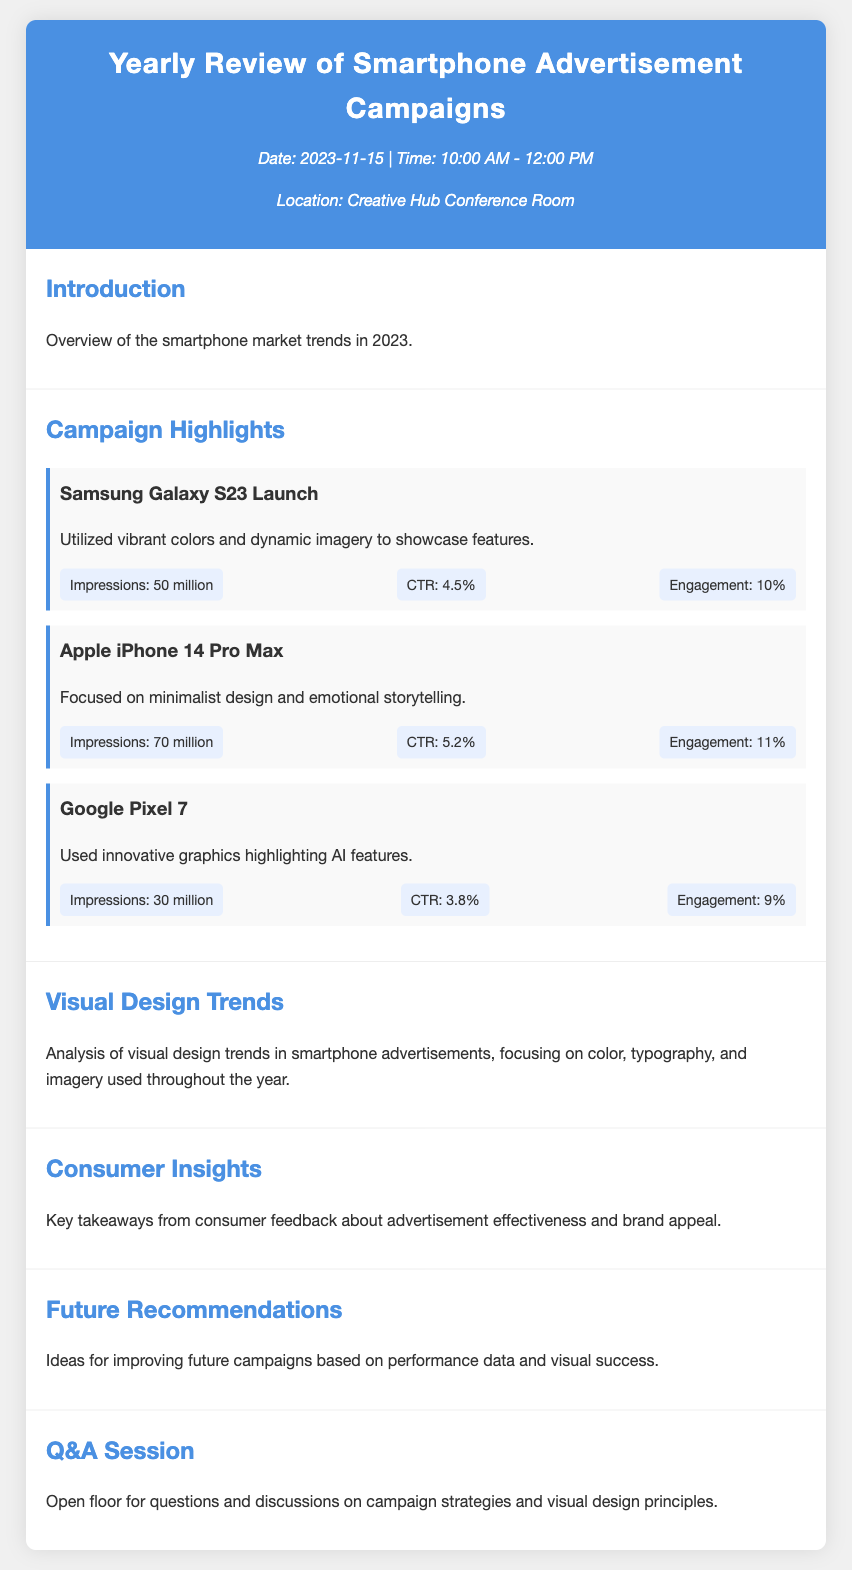What is the date of the review? The date is specified in the header of the document as 2023-11-15.
Answer: 2023-11-15 What is the engagement rate for the Apple iPhone 14 Pro Max campaign? The engagement rate is listed under the campaign highlights for Apple iPhone 14 Pro Max, which is 11%.
Answer: 11% How many impressions were achieved by the Samsung Galaxy S23 Launch? The impressions figure is provided in the campaign section for Samsung Galaxy S23, which is 50 million.
Answer: 50 million What design approach was emphasized in the Google Pixel 7 advertisement? The document states that the Google Pixel 7 used innovative graphics highlighting AI features.
Answer: Innovative graphics Which campaign had the highest click-through rate (CTR)? The CTRs are compared in the campaign highlights, revealing the Apple iPhone 14 Pro Max had the highest at 5.2%.
Answer: 5.2% What overall trend does the document analyze in the Visual Design Trends section? The analysis focuses on the use of color, typography, and imagery throughout the year in smartphone advertisements.
Answer: Color, typography, and imagery What is the purpose of the Q&A Session section? The Q&A Session section is meant for open discussions and questions regarding campaign strategies and visual design principles.
Answer: Open discussions Which smartphone brand launched the campaign with the least impressions? The Google Pixel 7 is noted for having the least impressions, with a figure of 30 million.
Answer: Google Pixel 7 What is one key takeaway from consumer insights listed in the document? The consumer insights section mentions effective advertisement impact and brand appeal.
Answer: Advertisement effectiveness and brand appeal 